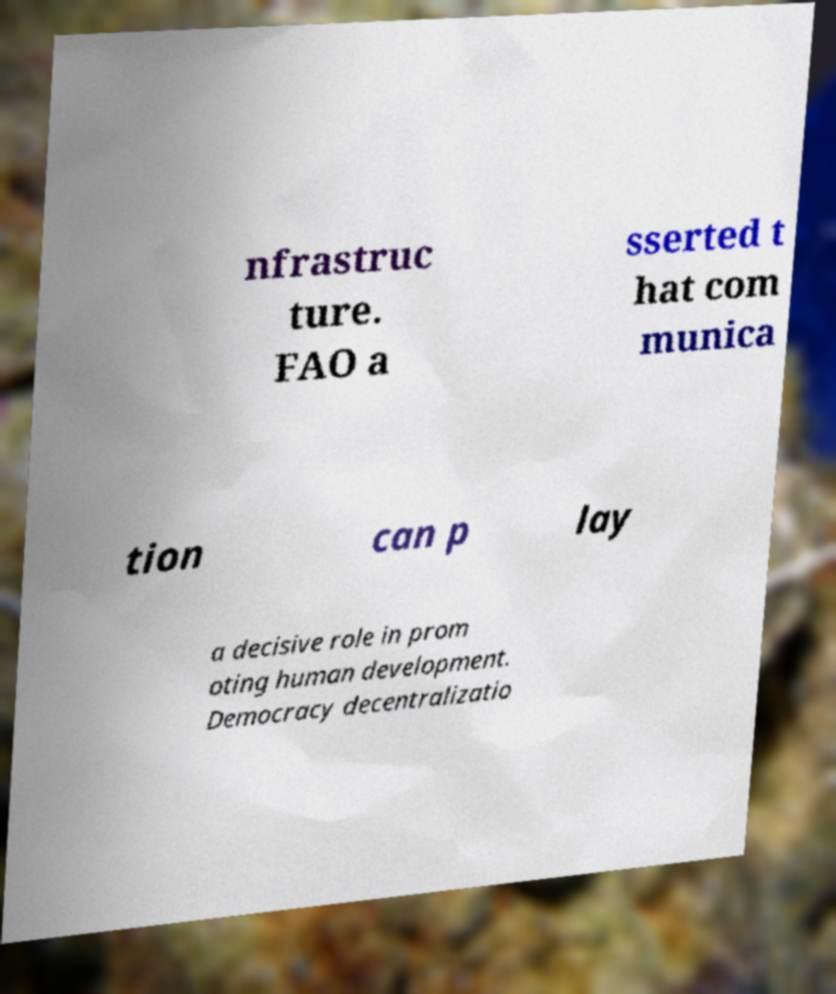Could you assist in decoding the text presented in this image and type it out clearly? nfrastruc ture. FAO a sserted t hat com munica tion can p lay a decisive role in prom oting human development. Democracy decentralizatio 